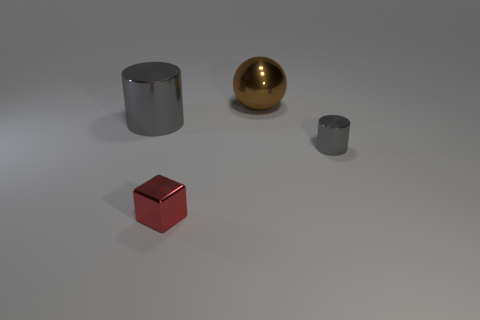Is the material of the gray cylinder that is to the left of the metallic sphere the same as the cylinder that is in front of the big metallic cylinder? Yes, the material of both cylinders appears to be the same. They both exhibit a matte finish and a consistent gray color, suggesting they are made from similar materials. Their surfaces do not reflect light as the golden sphere does, indicating they are not metallic but more likely a type of plastic or painted metal. 